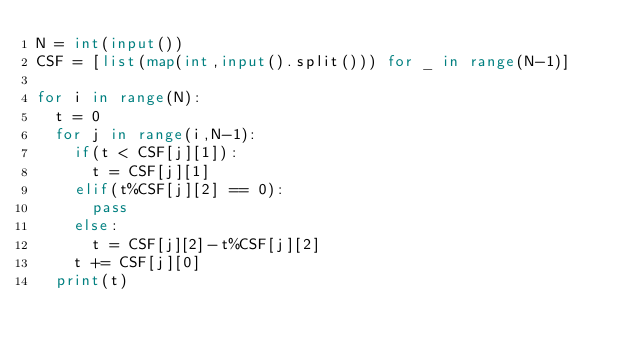Convert code to text. <code><loc_0><loc_0><loc_500><loc_500><_Python_>N = int(input())
CSF = [list(map(int,input().split())) for _ in range(N-1)]

for i in range(N):
  t = 0
  for j in range(i,N-1):
    if(t < CSF[j][1]):
      t = CSF[j][1]
    elif(t%CSF[j][2] == 0):
      pass
    else:
      t = CSF[j][2]-t%CSF[j][2]
    t += CSF[j][0]
  print(t)</code> 